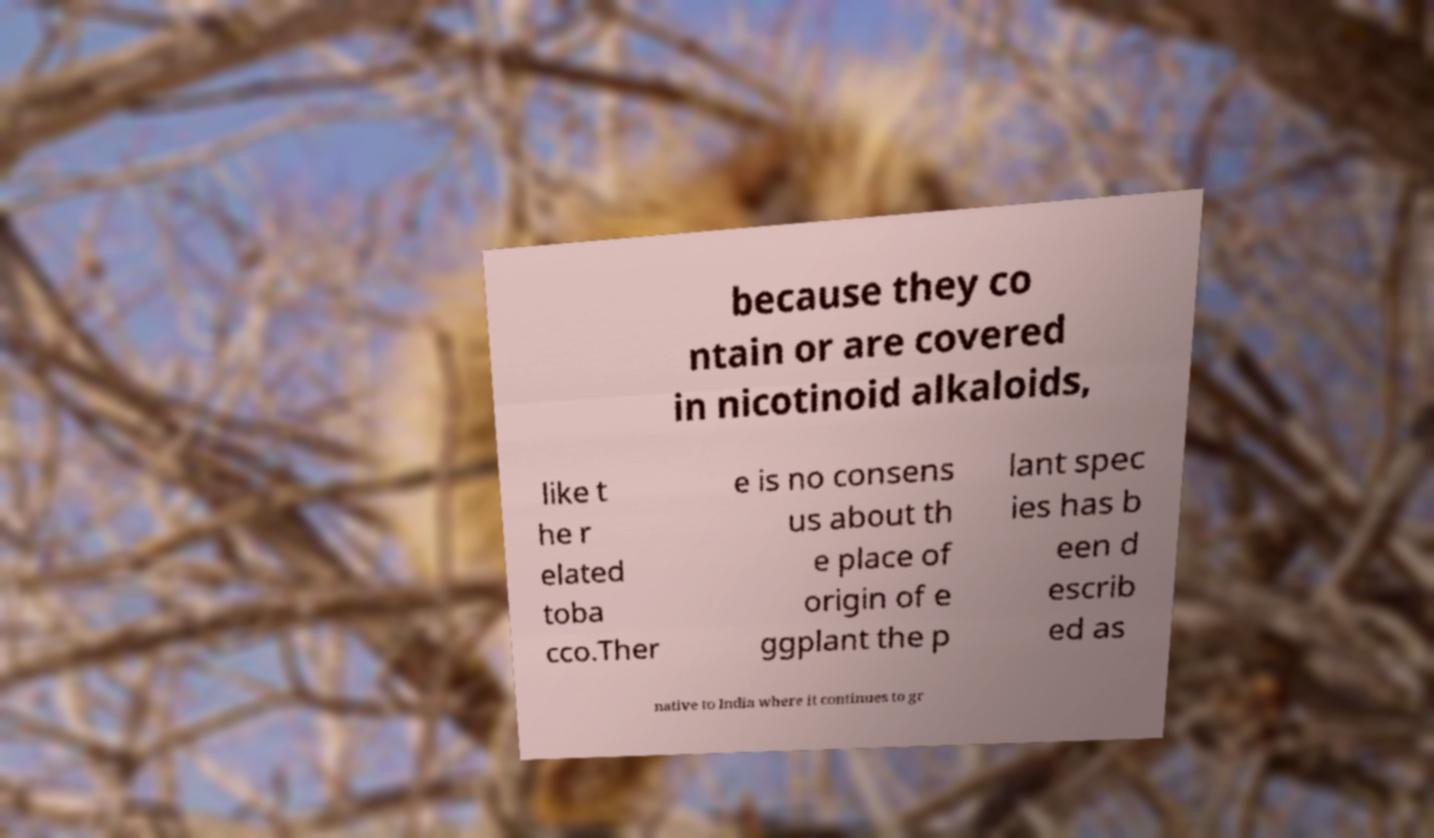Please read and relay the text visible in this image. What does it say? because they co ntain or are covered in nicotinoid alkaloids, like t he r elated toba cco.Ther e is no consens us about th e place of origin of e ggplant the p lant spec ies has b een d escrib ed as native to India where it continues to gr 